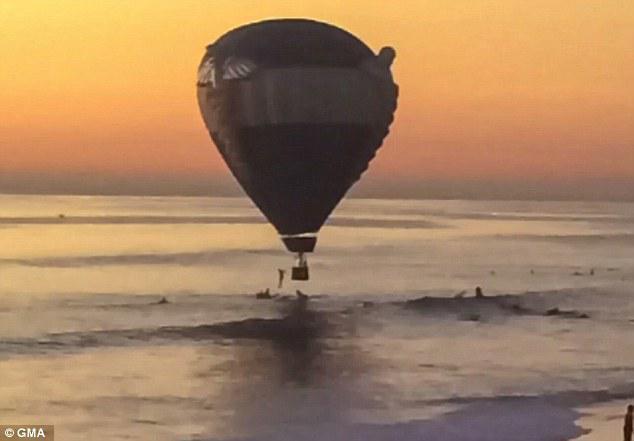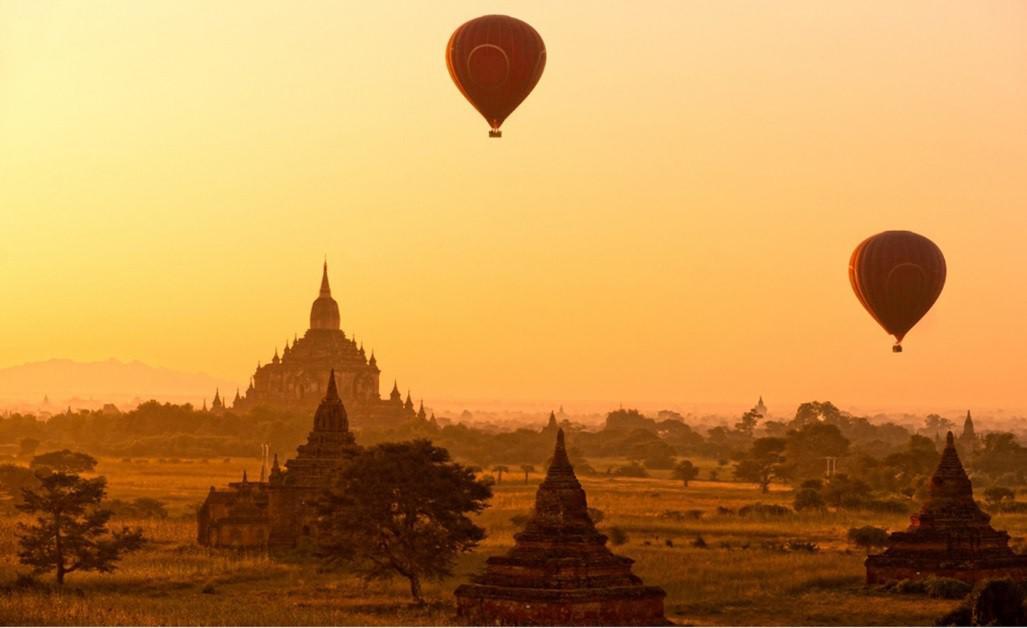The first image is the image on the left, the second image is the image on the right. Assess this claim about the two images: "At least one image has exactly three balloons.". Correct or not? Answer yes or no. No. The first image is the image on the left, the second image is the image on the right. Examine the images to the left and right. Is the description "There are three hot air balloons." accurate? Answer yes or no. Yes. 